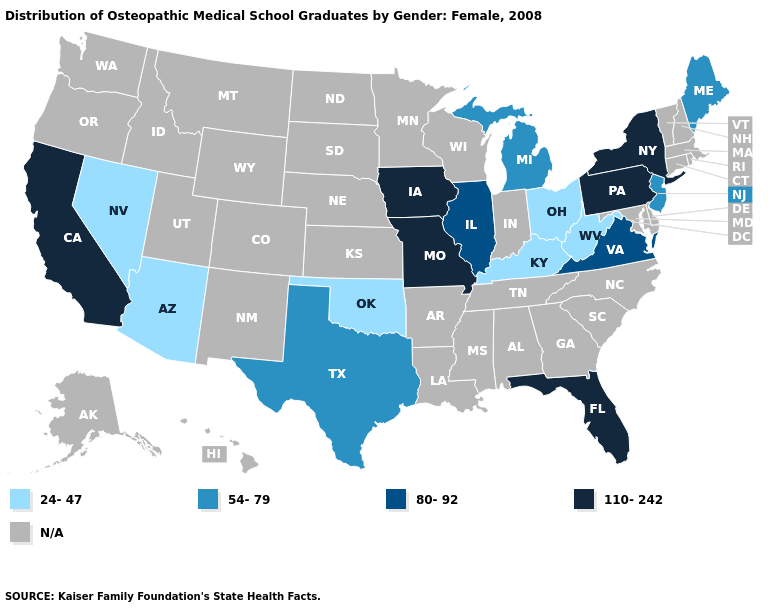Among the states that border Arkansas , does Oklahoma have the lowest value?
Keep it brief. Yes. Name the states that have a value in the range 110-242?
Write a very short answer. California, Florida, Iowa, Missouri, New York, Pennsylvania. What is the lowest value in the USA?
Keep it brief. 24-47. What is the highest value in the USA?
Write a very short answer. 110-242. Name the states that have a value in the range 24-47?
Be succinct. Arizona, Kentucky, Nevada, Ohio, Oklahoma, West Virginia. Among the states that border Alabama , which have the lowest value?
Give a very brief answer. Florida. What is the highest value in states that border California?
Write a very short answer. 24-47. Which states have the highest value in the USA?
Be succinct. California, Florida, Iowa, Missouri, New York, Pennsylvania. What is the value of Nebraska?
Give a very brief answer. N/A. Name the states that have a value in the range N/A?
Short answer required. Alabama, Alaska, Arkansas, Colorado, Connecticut, Delaware, Georgia, Hawaii, Idaho, Indiana, Kansas, Louisiana, Maryland, Massachusetts, Minnesota, Mississippi, Montana, Nebraska, New Hampshire, New Mexico, North Carolina, North Dakota, Oregon, Rhode Island, South Carolina, South Dakota, Tennessee, Utah, Vermont, Washington, Wisconsin, Wyoming. Is the legend a continuous bar?
Quick response, please. No. Name the states that have a value in the range 110-242?
Quick response, please. California, Florida, Iowa, Missouri, New York, Pennsylvania. Name the states that have a value in the range 54-79?
Give a very brief answer. Maine, Michigan, New Jersey, Texas. Name the states that have a value in the range 80-92?
Keep it brief. Illinois, Virginia. 